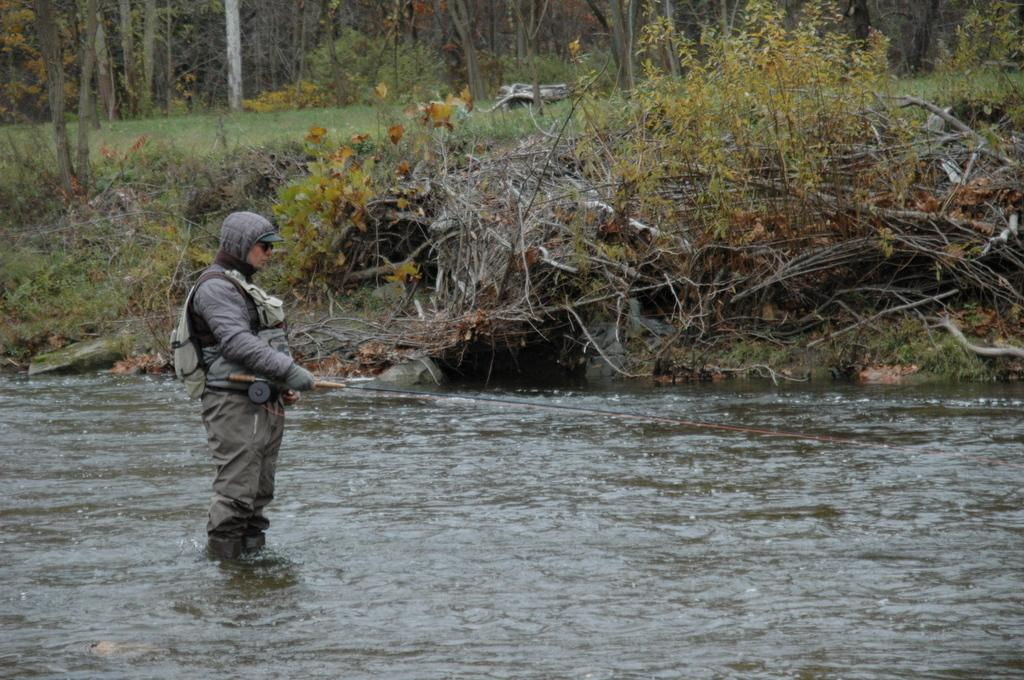What is the person in the image doing? The person is standing in the water. What object is the person holding? The person is holding a stick. What can be seen in the background of the image? There are trees and grass visible in the background of the image. What time of day is it in the image, and is the person's family present? The time of day is not mentioned in the image, and there is no information about the person's family being present. Is there a hospital visible in the image? There is no mention of a hospital in the image. 